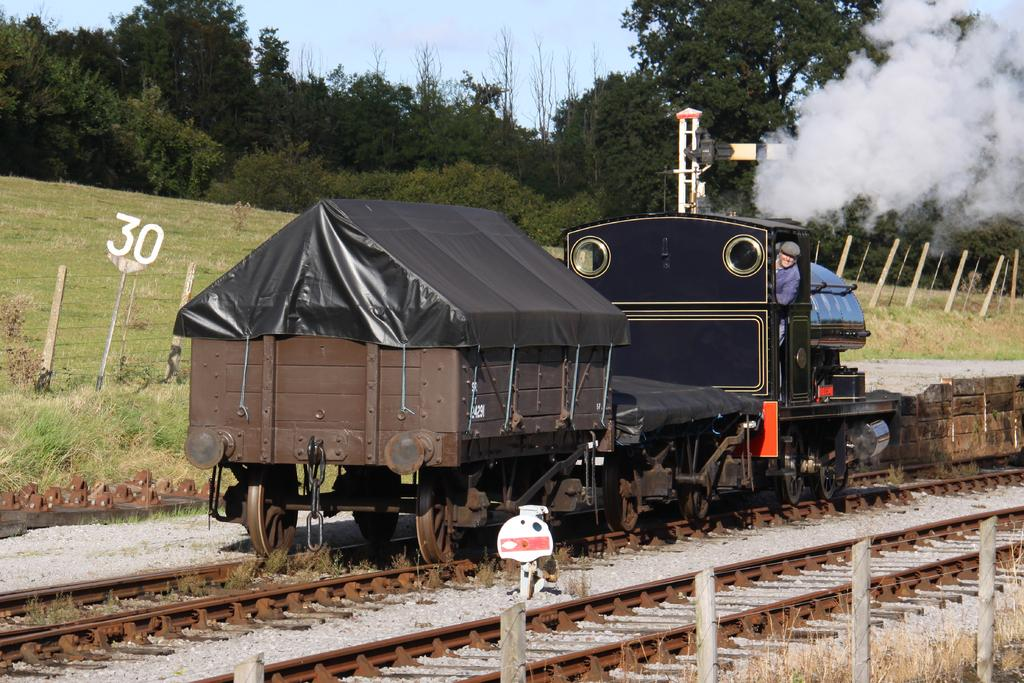What is the main subject of the image? The main subject of the image is a train. What is the train doing in the image? The train is moving on a track. Is there any indication of the train's activity in the image? Yes, the train is releasing smoke. What can be seen in the background of the image? There is grassland and trees visible in the background of the image. What part of the natural environment is visible in the image? The sky is visible in the image. How much throat can be seen in the image? There is no throat visible in the image; it features a train moving on a track and releasing smoke. 